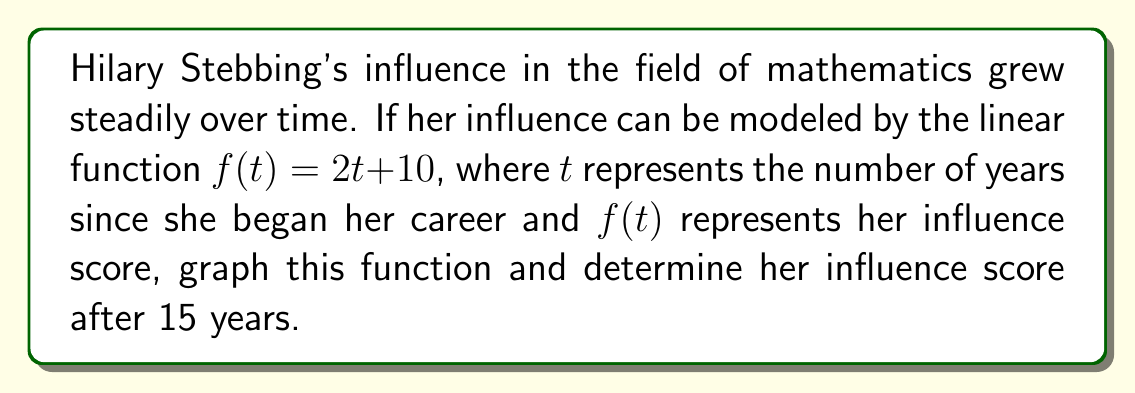What is the answer to this math problem? To solve this problem, we'll follow these steps:

1) First, let's identify the components of the linear function:
   $f(t) = 2t + 10$
   Slope (m) = 2
   y-intercept (b) = 10

2) To graph the function, we need two points. We can use the y-intercept (0, 10) and calculate another point:
   When t = 5, f(5) = 2(5) + 10 = 20
   So our second point is (5, 20)

3) Let's graph these points and draw the line:

[asy]
import graph;
size(200,200);
real f(real x) {return 2x + 10;}
xaxis("t (years)",arrow=Arrow);
yaxis("f(t) (influence score)",arrow=Arrow);
draw(graph(f,0,15));
dot((0,10));
dot((5,20));
dot((15,40));
label("(0,10)",(0,10),SW);
label("(5,20)",(5,20),NE);
label("(15,40)",(15,40),NE);
[/asy]

4) To find Hilary's influence score after 15 years, we substitute t = 15 into the function:
   $f(15) = 2(15) + 10 = 30 + 10 = 40$

Therefore, after 15 years, Hilary Stebbing's influence score would be 40.
Answer: 40 